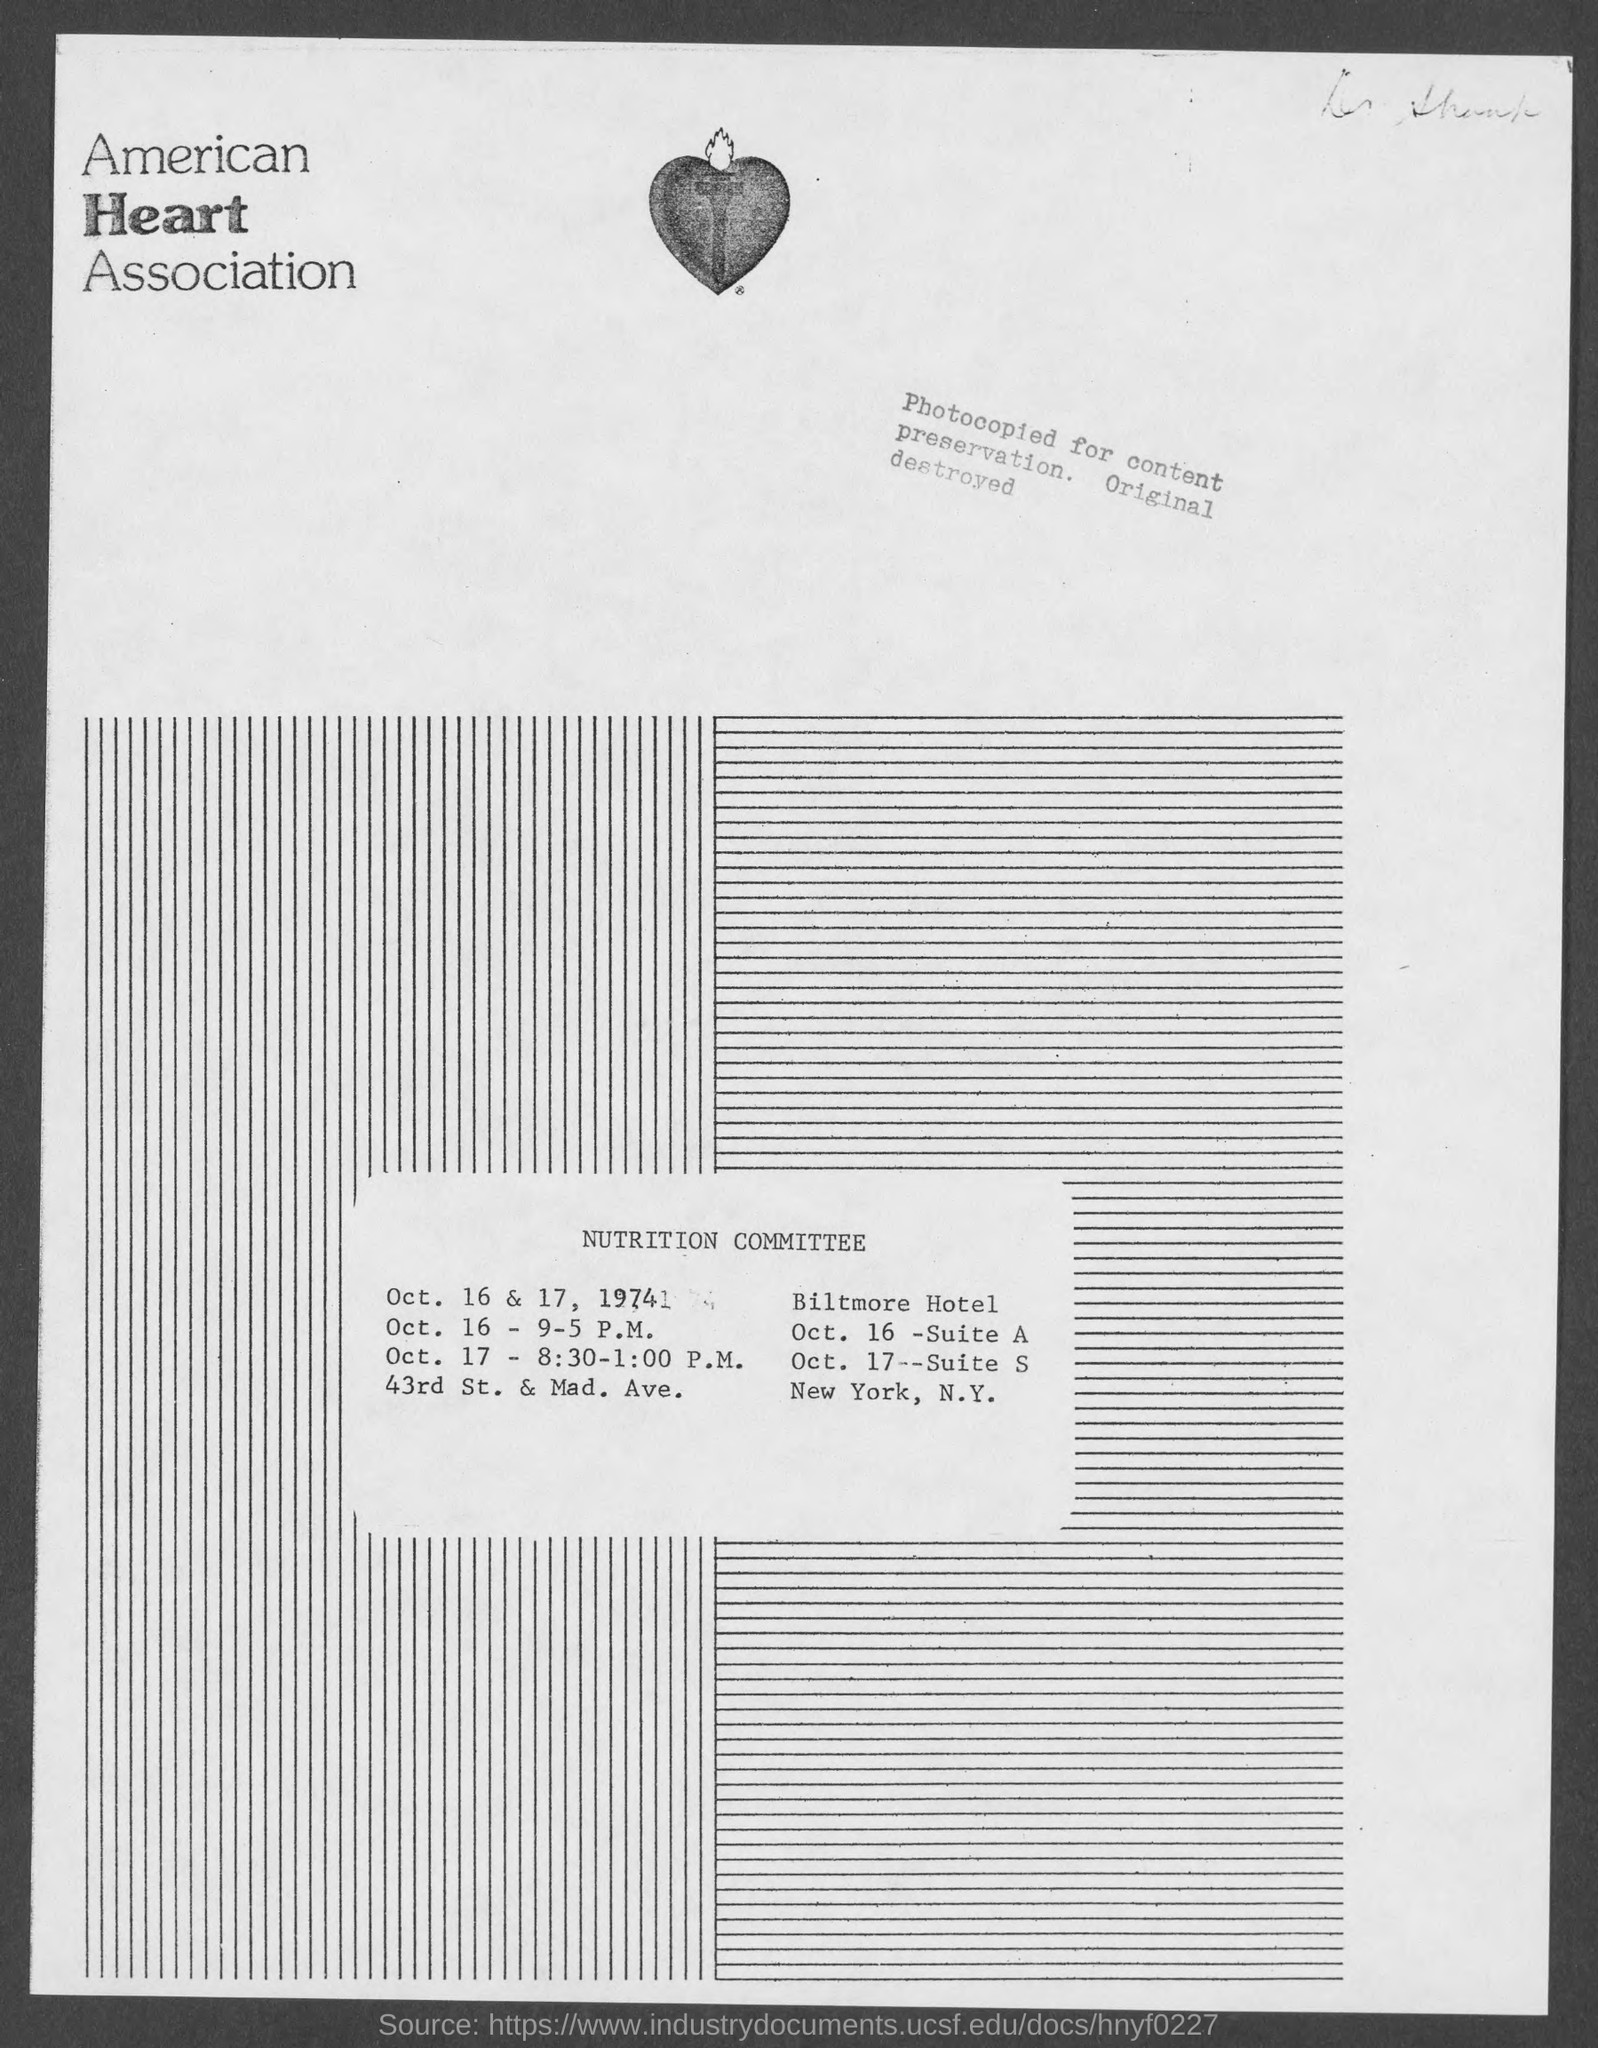Point out several critical features in this image. The name of the association is the American Heart Association. 